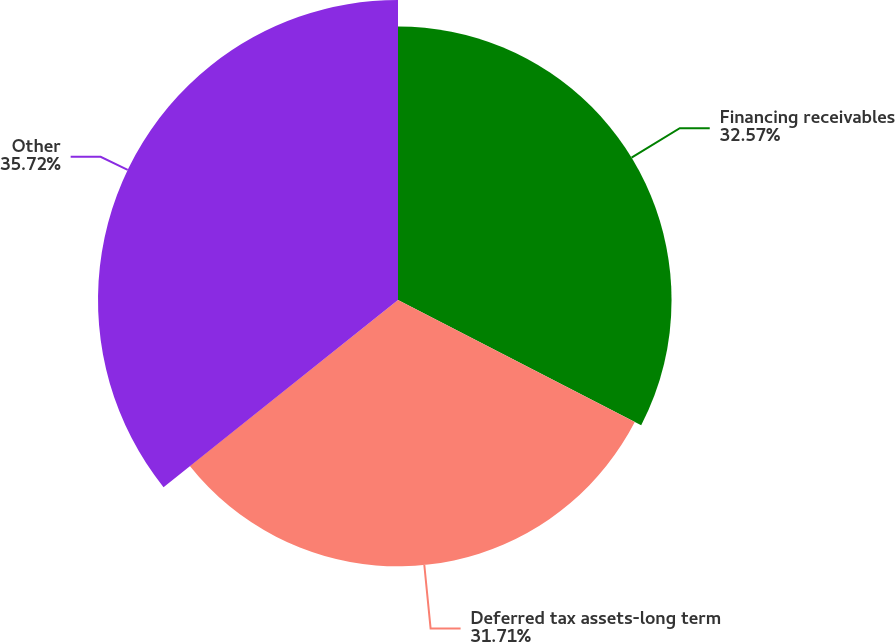<chart> <loc_0><loc_0><loc_500><loc_500><pie_chart><fcel>Financing receivables<fcel>Deferred tax assets-long term<fcel>Other<nl><fcel>32.57%<fcel>31.71%<fcel>35.72%<nl></chart> 